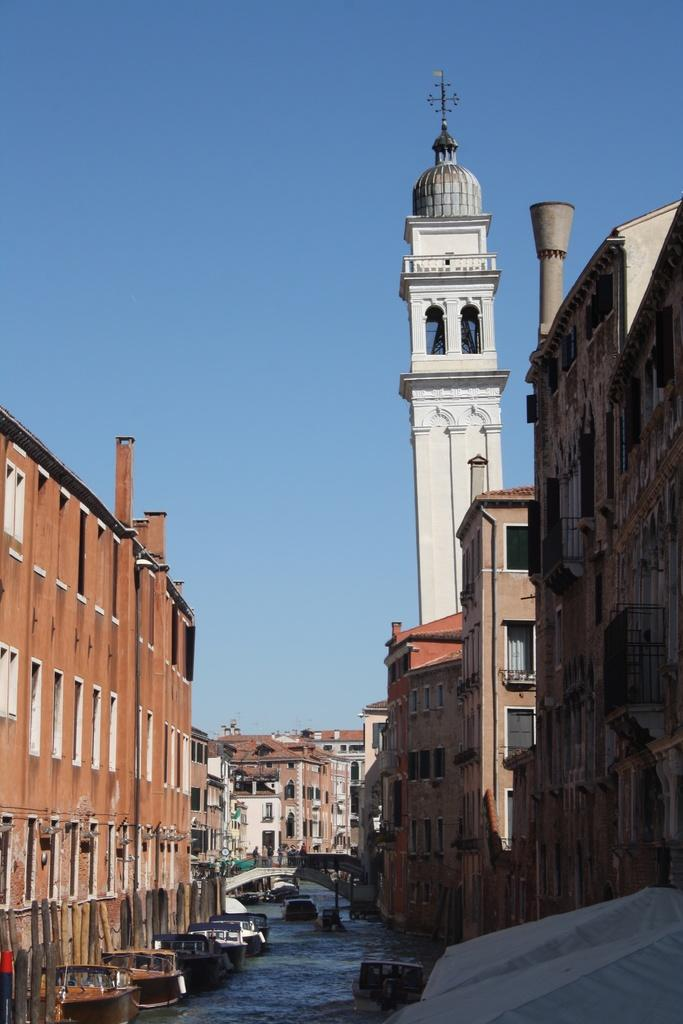What type of structures can be seen in the image? There are buildings in the image. What body of water is present at the bottom of the image? There is a canal at the bottom of the image. What is moving on the canal? Boats are visible on the canal. How can people cross the canal in the image? There is a bridge in the image. What can be seen in the background of the image? The sky is visible in the background of the image. Where is the vase located in the image? There is no vase present in the image. What type of bun is being prepared in the image? There is no bun or cooking activity depicted in the image. 